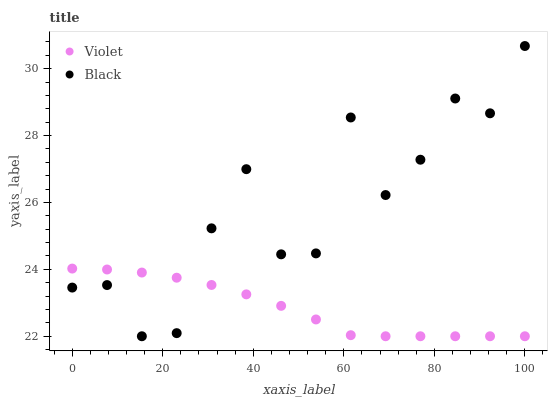Does Violet have the minimum area under the curve?
Answer yes or no. Yes. Does Black have the maximum area under the curve?
Answer yes or no. Yes. Does Violet have the maximum area under the curve?
Answer yes or no. No. Is Violet the smoothest?
Answer yes or no. Yes. Is Black the roughest?
Answer yes or no. Yes. Is Violet the roughest?
Answer yes or no. No. Does Black have the lowest value?
Answer yes or no. Yes. Does Black have the highest value?
Answer yes or no. Yes. Does Violet have the highest value?
Answer yes or no. No. Does Violet intersect Black?
Answer yes or no. Yes. Is Violet less than Black?
Answer yes or no. No. Is Violet greater than Black?
Answer yes or no. No. 